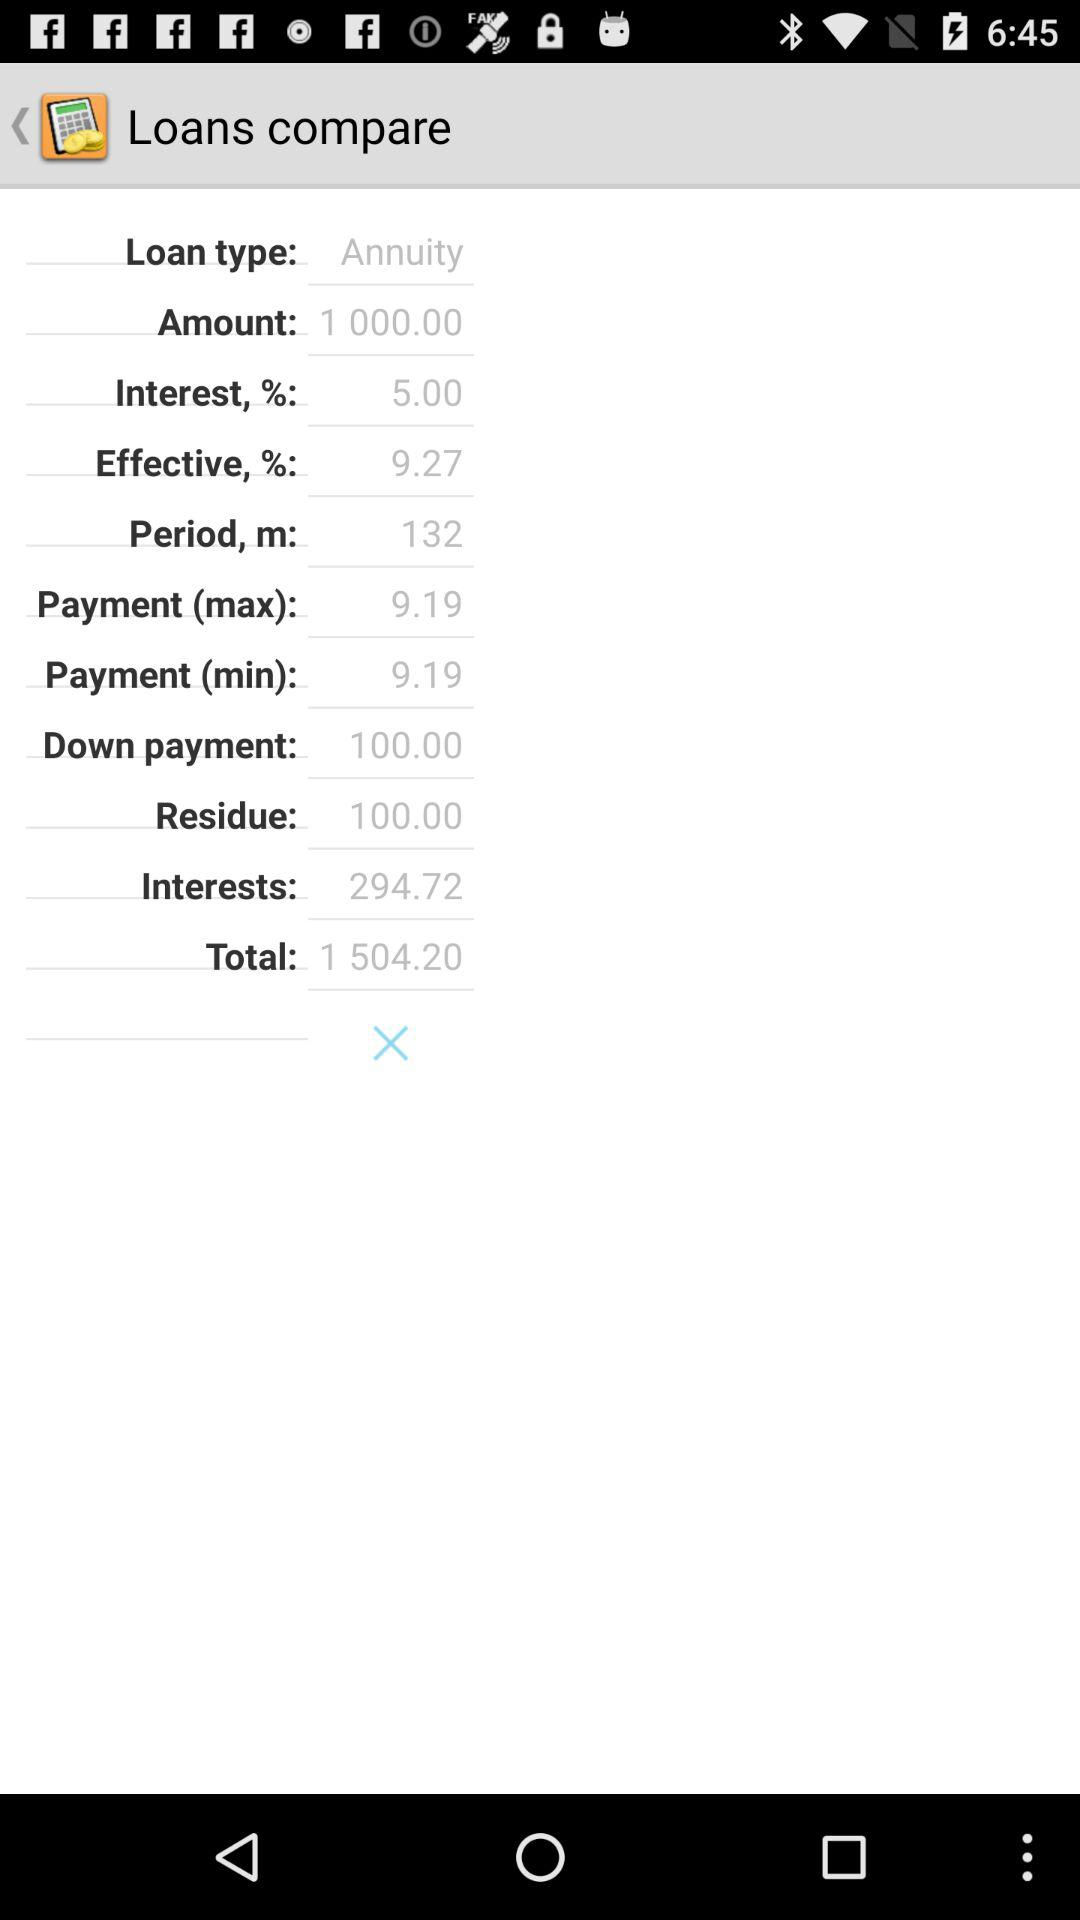What is the interest rate? The interest rate is 5%. 